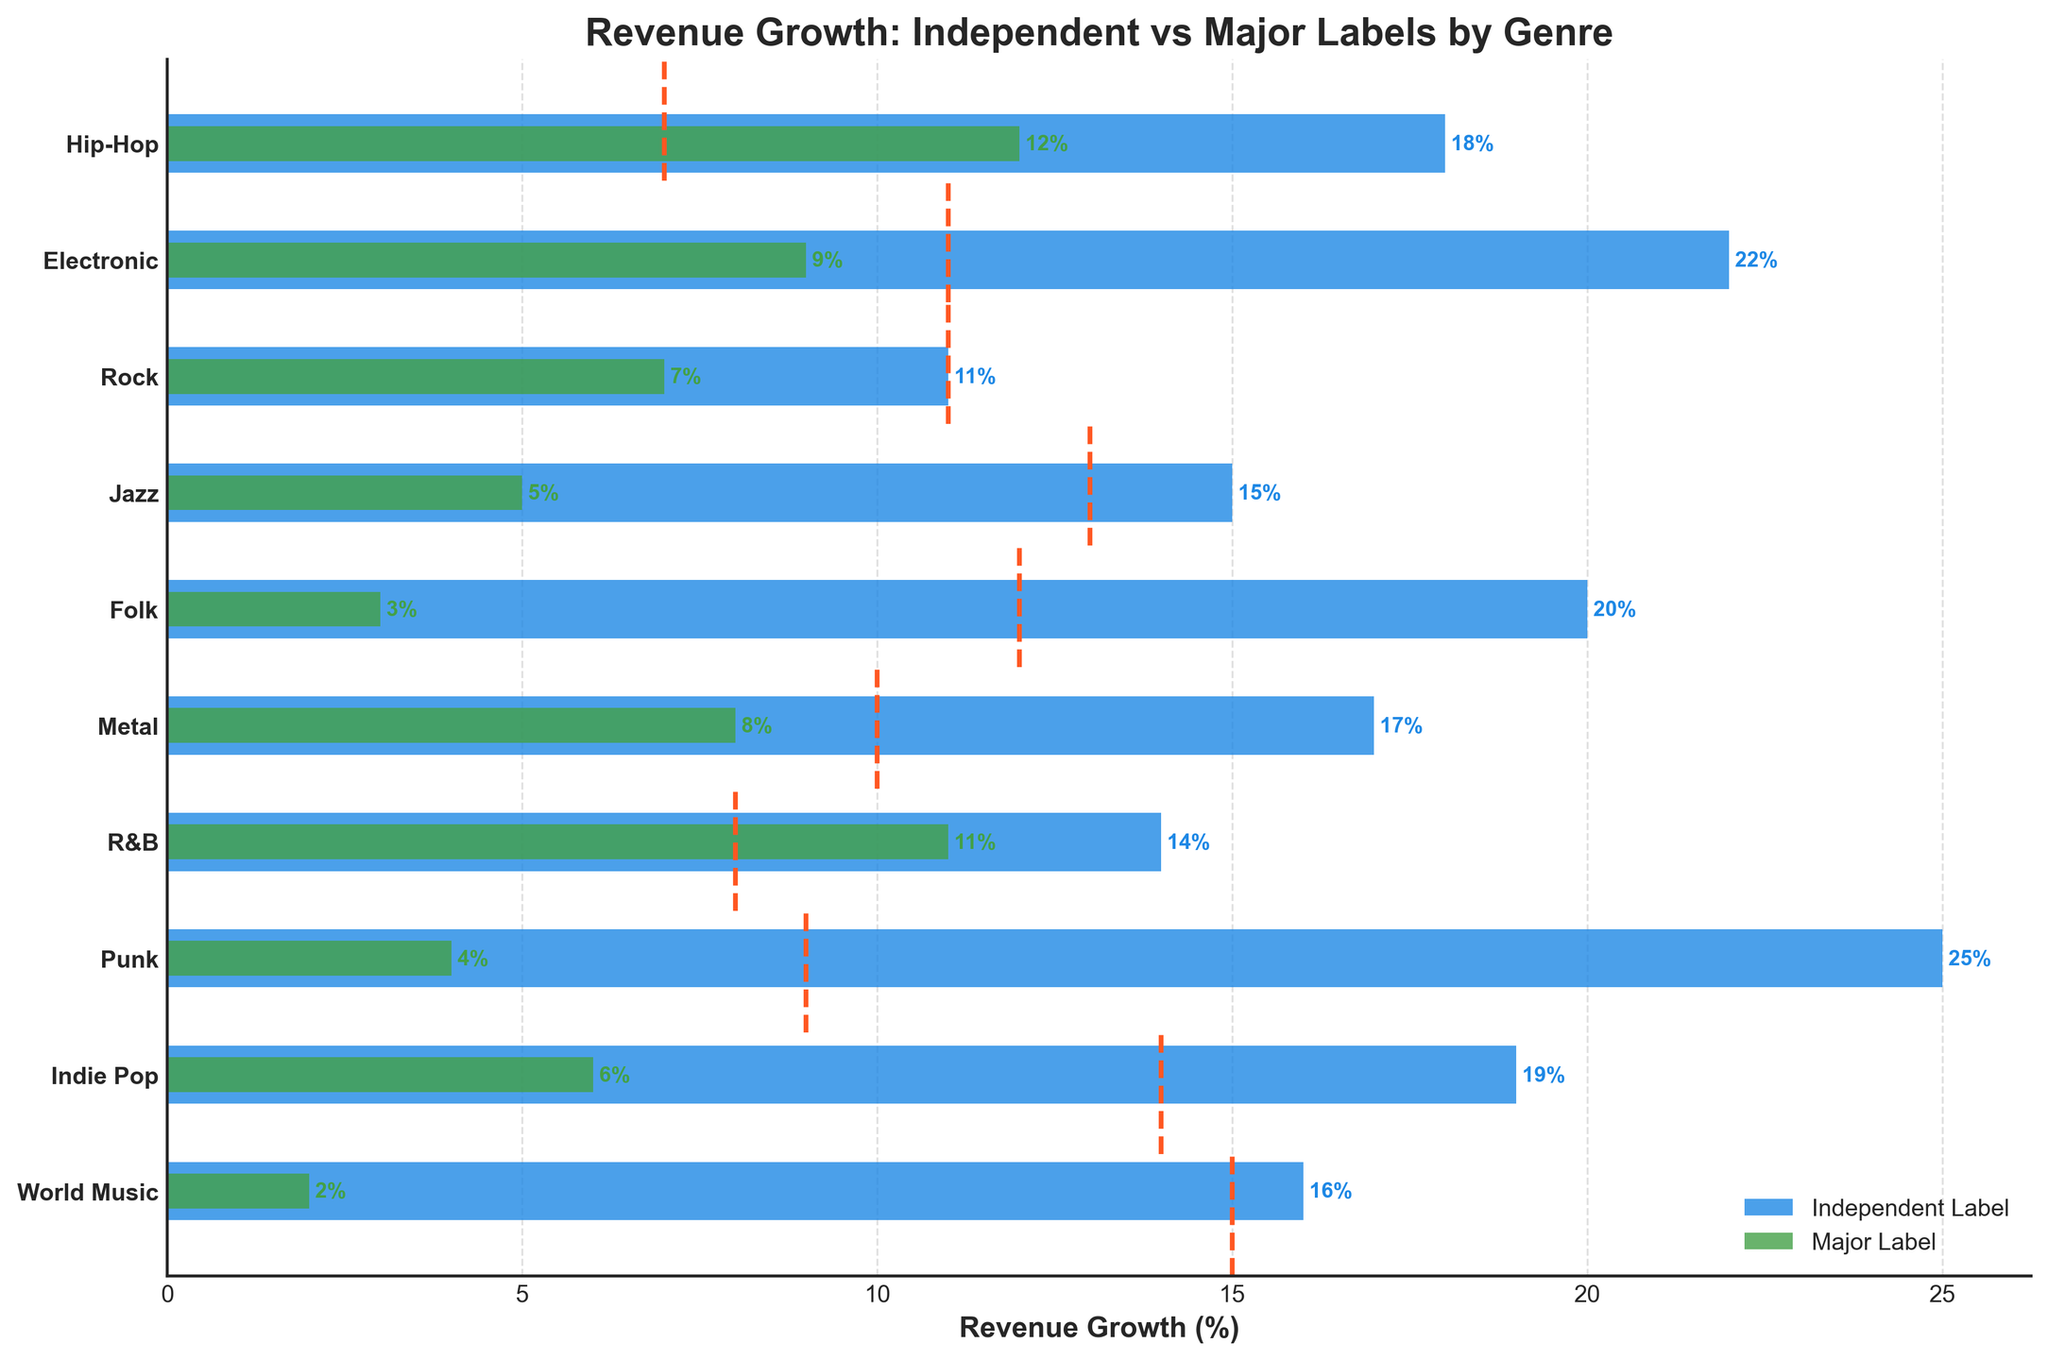What is the title of the plot? The title of the plot is displayed at the top. It provides a summary of the data being visualized.
Answer: Revenue Growth: Independent vs Major Labels by Genre Which genre shows the highest revenue growth for independent labels? To find the highest revenue growth for independent labels, look for the longest blue bar on the chart.
Answer: Punk How does the revenue growth of independent labels in World Music compare to major labels in the same genre? Compare the lengths of the blue and green bars labeled World Music. The blue bar (Independent Label) is much longer than the green bar (Major Labels).
Answer: Independent Labels have much higher revenue growth Which genre has the smallest difference in revenue growth between independent and major labels, and what is that difference? Calculate the differences between the blue and green bars for each genre and find the smallest one. For R&B, it's 14% - 11% = 3%.
Answer: R&B, 3% What is the average revenue growth for independent labels across all genres? Add the revenue growth percentages for independent labels and divide by the number of genres. (18 + 22 + 11 + 15 + 20 + 17 + 14 + 25 + 19 + 16) / 10 = 177 / 10
Answer: 17.7% Which genre has a higher revenue growth than the industry average for both independent and major labels? For each genre, check if both the blue and green bars are longer than the industry average dotted line. For Hip-Hop, Independent = 18%, Major = 12%, Industry Average = 15%. Hip-Hop meets this condition.
Answer: Hip-Hop What's the range of revenue growth for major labels across all genres? Subtract the smallest revenue growth percentage for major labels from the largest. Largest is 12% (Hip-Hop) and smallest is 2% (World Music). 12% - 2% = 10%
Answer: 10% In which genre do independent labels outperform the industry average by the largest margin? Find the genre where the difference between the blue bar and the dotted line is the largest. For Punk, it's 25% - 11% = 14%.
Answer: Punk What is the revenue growth for major labels in Jazz, and how does it compare to the industry average for Jazz? Look at the green bar for Jazz (5%) and compare it to the dotted line for Jazz (8%). Major Labels are below the industry average.
Answer: 5%, below industry average How many genres have an independent label revenue growth above 20%? Count the genres where the blue bar is above 20%. Electronic, Folk, and Punk meet this condition.
Answer: 3 genres 